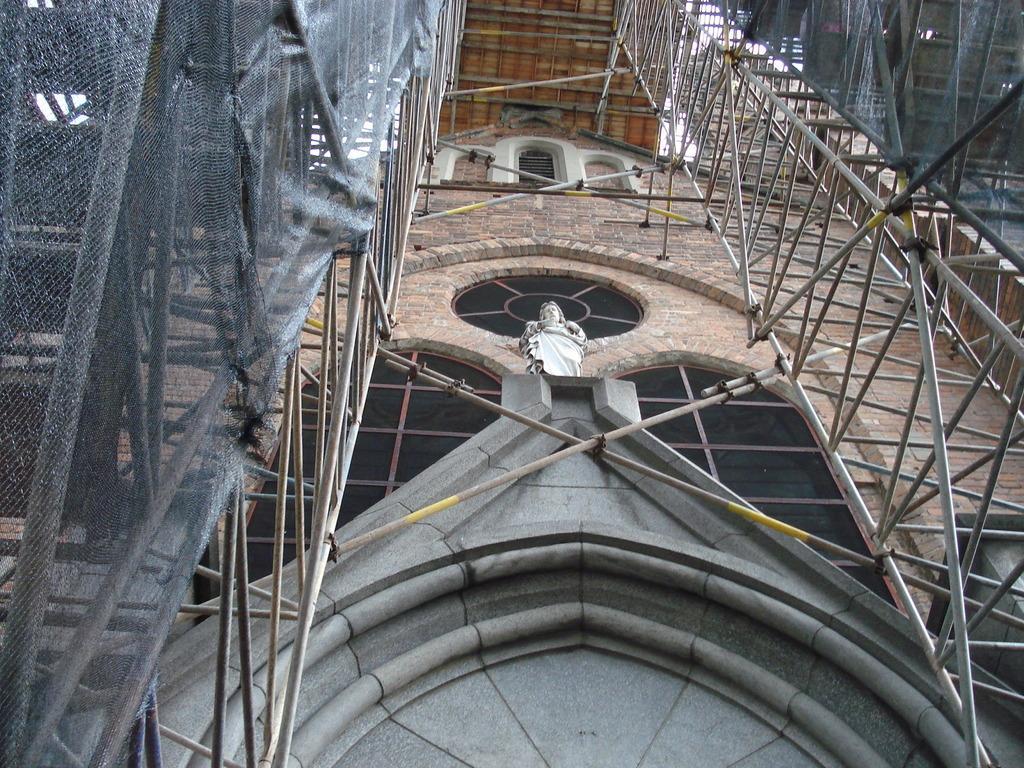Describe this image in one or two sentences. In this image I can see there is a construction of a building. In the middle there is the statue. 